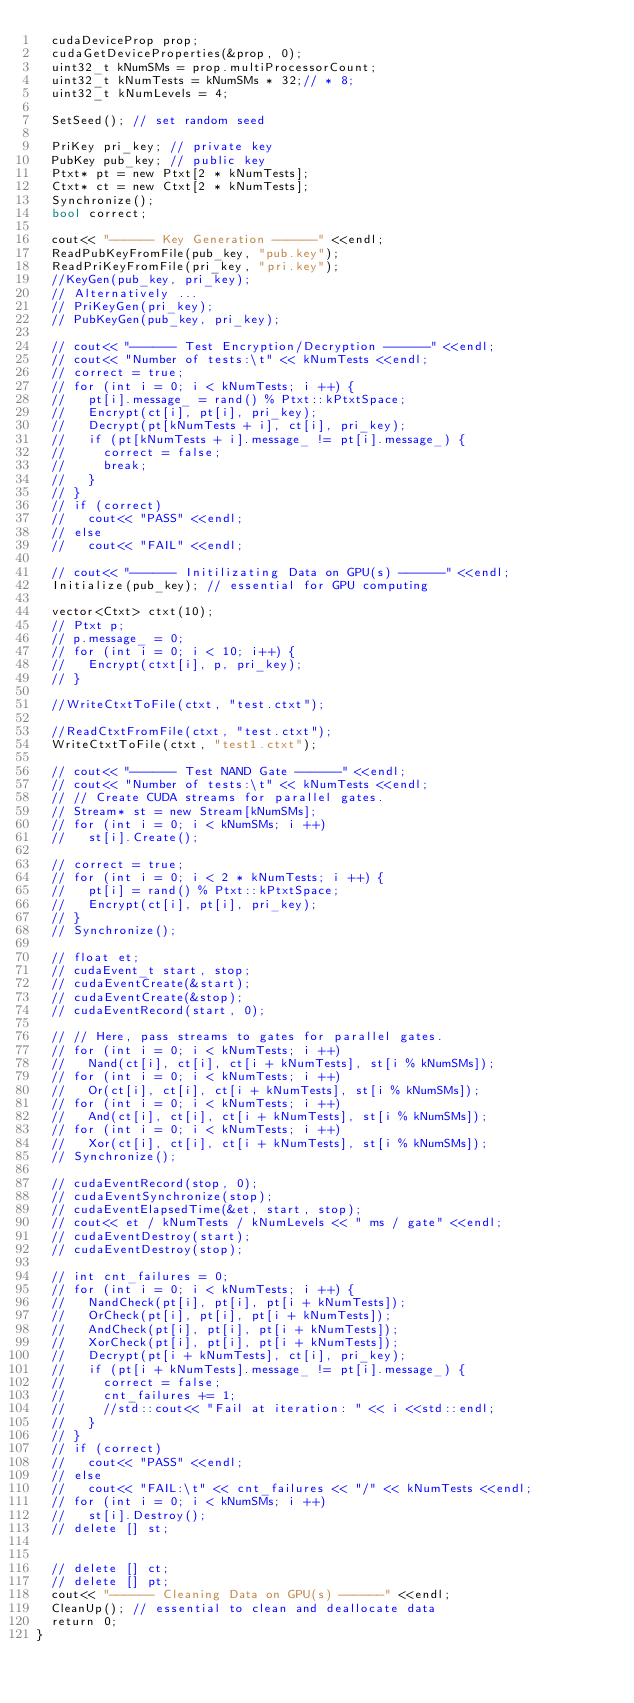Convert code to text. <code><loc_0><loc_0><loc_500><loc_500><_Cuda_>  cudaDeviceProp prop;
  cudaGetDeviceProperties(&prop, 0);
  uint32_t kNumSMs = prop.multiProcessorCount;
  uint32_t kNumTests = kNumSMs * 32;// * 8;
  uint32_t kNumLevels = 4;

  SetSeed(); // set random seed

  PriKey pri_key; // private key
  PubKey pub_key; // public key
  Ptxt* pt = new Ptxt[2 * kNumTests];
  Ctxt* ct = new Ctxt[2 * kNumTests];
  Synchronize();
  bool correct;

  cout<< "------ Key Generation ------" <<endl;
  ReadPubKeyFromFile(pub_key, "pub.key");
  ReadPriKeyFromFile(pri_key, "pri.key");
  //KeyGen(pub_key, pri_key);
  // Alternatively ...
  // PriKeyGen(pri_key);
  // PubKeyGen(pub_key, pri_key);

  // cout<< "------ Test Encryption/Decryption ------" <<endl;
  // cout<< "Number of tests:\t" << kNumTests <<endl;
  // correct = true;
  // for (int i = 0; i < kNumTests; i ++) {
  //   pt[i].message_ = rand() % Ptxt::kPtxtSpace;
  //   Encrypt(ct[i], pt[i], pri_key);
  //   Decrypt(pt[kNumTests + i], ct[i], pri_key);
  //   if (pt[kNumTests + i].message_ != pt[i].message_) {
  //     correct = false;
  //     break;
  //   }
  // }
  // if (correct)
  //   cout<< "PASS" <<endl;
  // else
  //   cout<< "FAIL" <<endl;

  // cout<< "------ Initilizating Data on GPU(s) ------" <<endl;
  Initialize(pub_key); // essential for GPU computing

  vector<Ctxt> ctxt(10);
  // Ptxt p;
  // p.message_ = 0;
  // for (int i = 0; i < 10; i++) {
  //   Encrypt(ctxt[i], p, pri_key);
  // }

  //WriteCtxtToFile(ctxt, "test.ctxt");

  //ReadCtxtFromFile(ctxt, "test.ctxt");
  WriteCtxtToFile(ctxt, "test1.ctxt");

  // cout<< "------ Test NAND Gate ------" <<endl;
  // cout<< "Number of tests:\t" << kNumTests <<endl;
  // // Create CUDA streams for parallel gates.
  // Stream* st = new Stream[kNumSMs];
  // for (int i = 0; i < kNumSMs; i ++)
  //   st[i].Create();

  // correct = true;
  // for (int i = 0; i < 2 * kNumTests; i ++) {
  //   pt[i] = rand() % Ptxt::kPtxtSpace;
  //   Encrypt(ct[i], pt[i], pri_key);
  // }
  // Synchronize();

  // float et;
  // cudaEvent_t start, stop;
  // cudaEventCreate(&start);
  // cudaEventCreate(&stop);
  // cudaEventRecord(start, 0);

  // // Here, pass streams to gates for parallel gates.
  // for (int i = 0; i < kNumTests; i ++)
  //   Nand(ct[i], ct[i], ct[i + kNumTests], st[i % kNumSMs]);
  // for (int i = 0; i < kNumTests; i ++)
  //   Or(ct[i], ct[i], ct[i + kNumTests], st[i % kNumSMs]);
  // for (int i = 0; i < kNumTests; i ++)
  //   And(ct[i], ct[i], ct[i + kNumTests], st[i % kNumSMs]);
  // for (int i = 0; i < kNumTests; i ++)
  //   Xor(ct[i], ct[i], ct[i + kNumTests], st[i % kNumSMs]);
  // Synchronize();

  // cudaEventRecord(stop, 0);
  // cudaEventSynchronize(stop);
  // cudaEventElapsedTime(&et, start, stop);
  // cout<< et / kNumTests / kNumLevels << " ms / gate" <<endl;
  // cudaEventDestroy(start);
  // cudaEventDestroy(stop);

  // int cnt_failures = 0;
  // for (int i = 0; i < kNumTests; i ++) {
  //   NandCheck(pt[i], pt[i], pt[i + kNumTests]);
  //   OrCheck(pt[i], pt[i], pt[i + kNumTests]);
  //   AndCheck(pt[i], pt[i], pt[i + kNumTests]);
  //   XorCheck(pt[i], pt[i], pt[i + kNumTests]);
  //   Decrypt(pt[i + kNumTests], ct[i], pri_key);
  //   if (pt[i + kNumTests].message_ != pt[i].message_) {
  //     correct = false;
  //     cnt_failures += 1;
  //     //std::cout<< "Fail at iteration: " << i <<std::endl;
  //   }
  // }
  // if (correct)
  //   cout<< "PASS" <<endl;
  // else
  //   cout<< "FAIL:\t" << cnt_failures << "/" << kNumTests <<endl;
  // for (int i = 0; i < kNumSMs; i ++)
  //   st[i].Destroy();
  // delete [] st;

  
  // delete [] ct;
  // delete [] pt;
  cout<< "------ Cleaning Data on GPU(s) ------" <<endl;
  CleanUp(); // essential to clean and deallocate data
  return 0;
}
</code> 